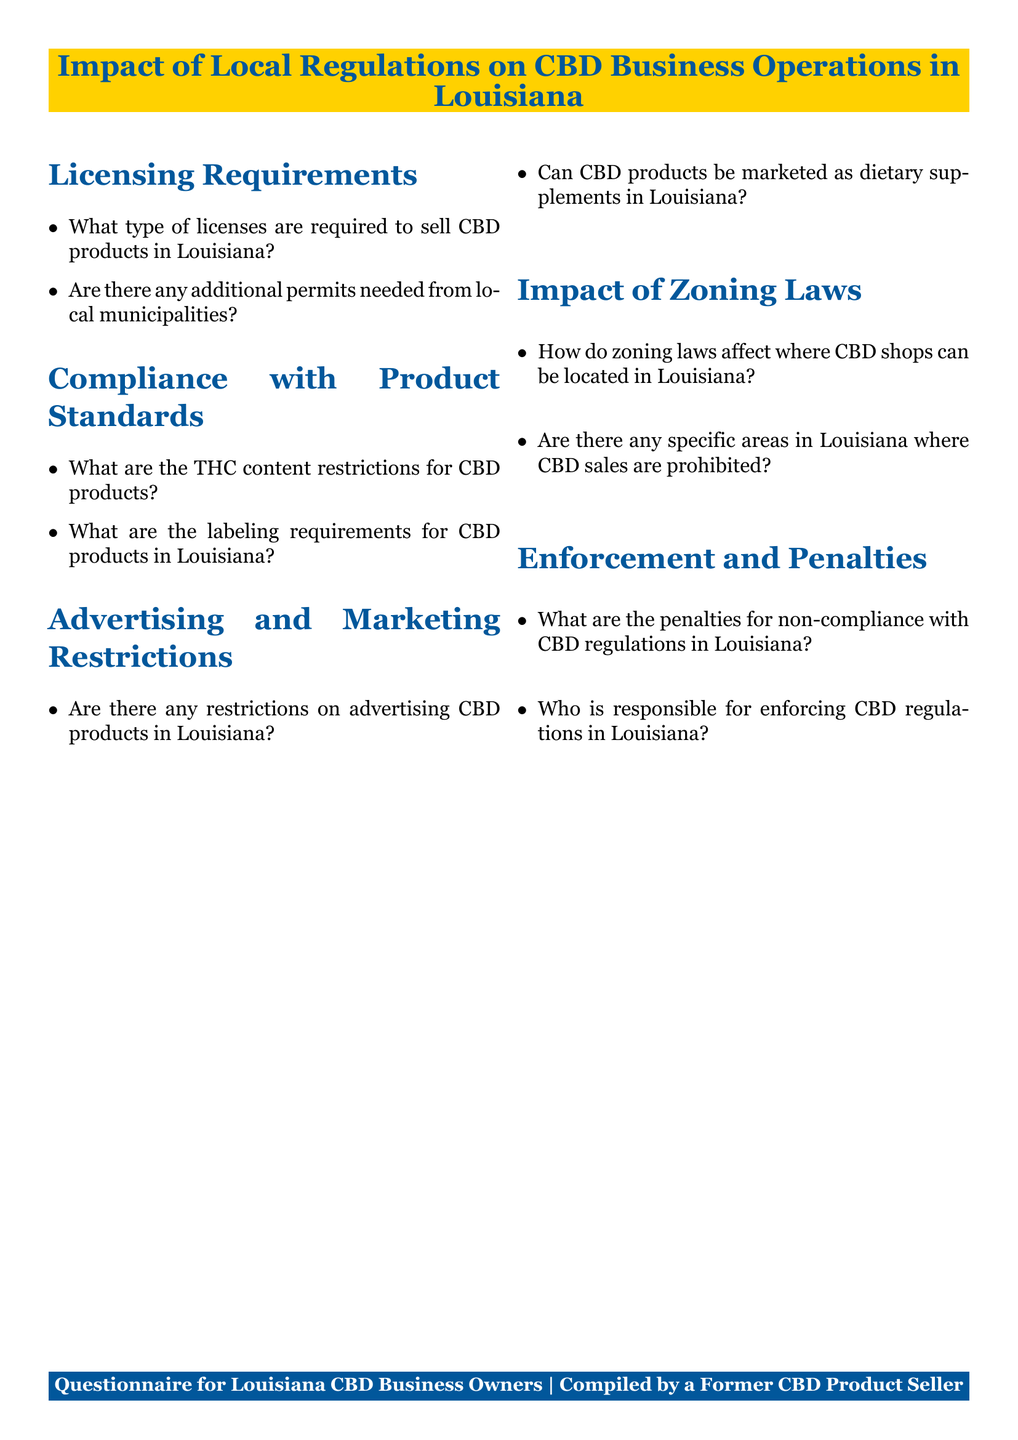what type of licenses are required to sell CBD products in Louisiana? This question retrieves specific information listed under the Licensing Requirements section of the document.
Answer: Specific licenses are there any additional permits needed from local municipalities? This question seeks information about whether local permits are required according to the Licensing Requirements section.
Answer: Yes what are the THC content restrictions for CBD products? The question looks for details on THC content found in the Compliance with Product Standards section.
Answer: Specific restrictions what are the labeling requirements for CBD products in Louisiana? This query aims to extract information relevant to labeling from the Compliance with Product Standards section.
Answer: Specific requirements are there any restrictions on advertising CBD products in Louisiana? This question retrieves information regarding advertising restrictions as mentioned in the Advertising and Marketing Restrictions section.
Answer: Yes can CBD products be marketed as dietary supplements in Louisiana? This question focuses on the marketing aspect of CBD products as noted in the Advertising and Marketing Restrictions section.
Answer: No how do zoning laws affect where CBD shops can be located in Louisiana? This question requires reasoning over the implications of zoning laws discussed in the Impact of Zoning Laws section.
Answer: Limit location are there any specific areas in Louisiana where CBD sales are prohibited? This question aims to find information about prohibited areas, relating to zoning laws discussed in the document.
Answer: Yes what are the penalties for non-compliance with CBD regulations in Louisiana? This question focuses on the consequences of non-compliance as outlined in the Enforcement and Penalties section.
Answer: Specific penalties who is responsible for enforcing CBD regulations in Louisiana? This question retrieves information about enforcement responsibilities noted in the Enforcement and Penalties section.
Answer: Enforcement agency 